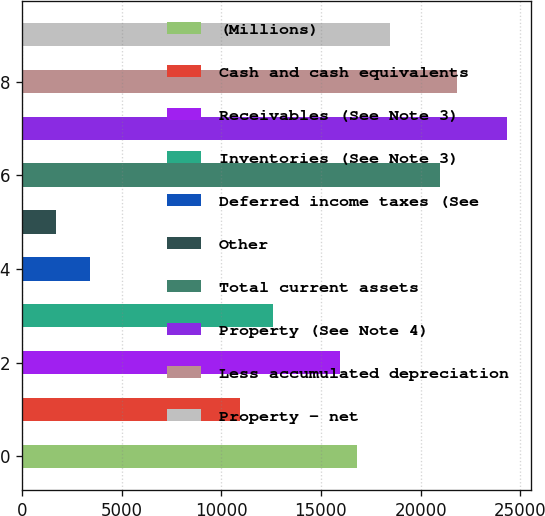Convert chart. <chart><loc_0><loc_0><loc_500><loc_500><bar_chart><fcel>(Millions)<fcel>Cash and cash equivalents<fcel>Receivables (See Note 3)<fcel>Inventories (See Note 3)<fcel>Deferred income taxes (See<fcel>Other<fcel>Total current assets<fcel>Property (See Note 4)<fcel>Less accumulated depreciation<fcel>Property - net<nl><fcel>16788<fcel>10933.2<fcel>15951.6<fcel>12606<fcel>3405.6<fcel>1732.8<fcel>20970<fcel>24315.6<fcel>21806.4<fcel>18460.8<nl></chart> 